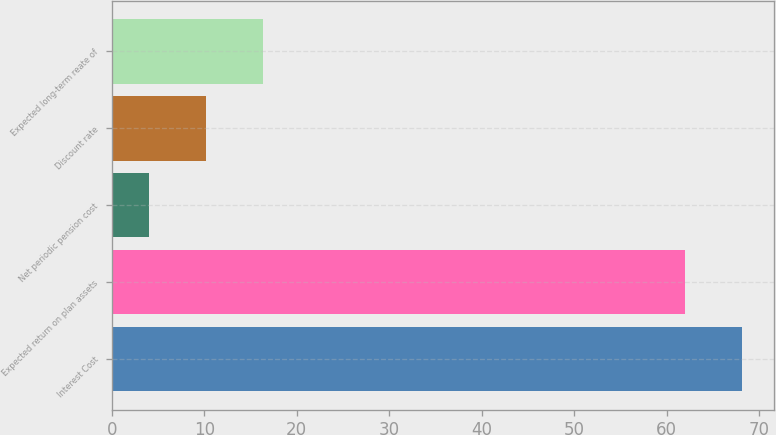Convert chart. <chart><loc_0><loc_0><loc_500><loc_500><bar_chart><fcel>Interest Cost<fcel>Expected return on plan assets<fcel>Net periodic pension cost<fcel>Discount rate<fcel>Expected long-term reate of<nl><fcel>68.2<fcel>62<fcel>4<fcel>10.2<fcel>16.4<nl></chart> 